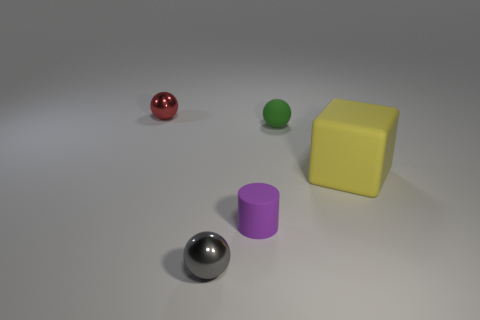Subtract all shiny balls. How many balls are left? 1 Add 2 cyan matte cylinders. How many objects exist? 7 Subtract all balls. How many objects are left? 2 Subtract all green spheres. How many spheres are left? 2 Subtract 1 cylinders. How many cylinders are left? 0 Subtract all blue cylinders. How many gray spheres are left? 1 Add 2 green rubber things. How many green rubber things are left? 3 Add 4 big red rubber balls. How many big red rubber balls exist? 4 Subtract 0 yellow spheres. How many objects are left? 5 Subtract all purple cubes. Subtract all green cylinders. How many cubes are left? 1 